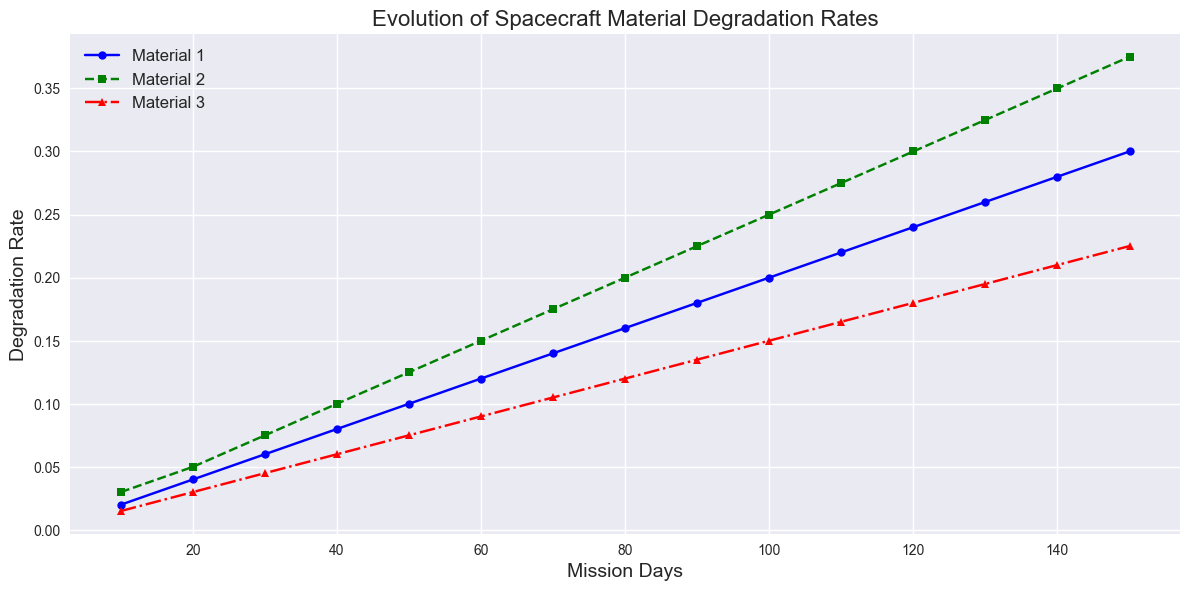What is the degradation rate of Material 1 at 50 mission days? Find the point on the plot where the x-axis is 50 mission days and check the y-axis value for Material 1's line, which is blue. The point corresponds to a y-axis value of 0.1.
Answer: 0.1 Which material shows the highest degradation rate at 90 mission days? Find the x-axis value of 90 and compare the y-axis values of all three materials at that point. Material 2's green line has the highest y-axis value at 0.225, which is higher than the other two materials.
Answer: Material 2 Over the 150 mission days, which material shows the least increase in degradation rate? Calculate the increase for each material from day 0 to day 150. Material 1 increases from 0 to 0.3 (0.3 increase), Material 2 from 0 to 0.375 (0.375 increase), and Material 3 from 0 to 0.225 (0.225 increase). Material 3 has the smallest increase.
Answer: Material 3 What is the difference in degradation rate between Material 1 and Material 3 at 60 mission days? Find the y-axis values for both materials at 60 mission days. Material 1 is at 0.12, and Material 3 is at 0.09. Subtract Material 3's value from Material 1's value: 0.12 - 0.09 = 0.03.
Answer: 0.03 By how much does Material 2’s degradation rate increase from 30 to 120 mission days? Find the y-axis values for Material 2 at 30 and 120 mission days. At 30 days, the rate is 0.075, and at 120 days, it is 0.3. Subtract the value at 30 days from the value at 120 days: 0.3 - 0.075 = 0.225.
Answer: 0.225 At which mission day do Material 1 and Material 3 have the same degradation rate? Look for the intersection of the blue and red lines. This occurs at around 40 mission days where both lines meet at the same y-axis value of 0.06.
Answer: 40 Which material shows the steadiest (most linear) increase in degradation rate over the mission days? Compare the trend lines of the materials visually. Material 1's blue line shows a consistent, steady linear increase without sharp changes in slope.
Answer: Material 1 What can be inferred about the overall trend for all materials? Observe the general direction of the lines for all three materials. All materials show a continuous increase in degradation rate as mission days increase.
Answer: All materials degrade over time What is the degradation rate of Material 2 at the halfway point (75 mission days)? Find the y-axis value for Material 2 (green line) at 75 mission days. The value is approximately halfway between 0.175 and 0.2. This measures about 0.1875.
Answer: 0.1875 